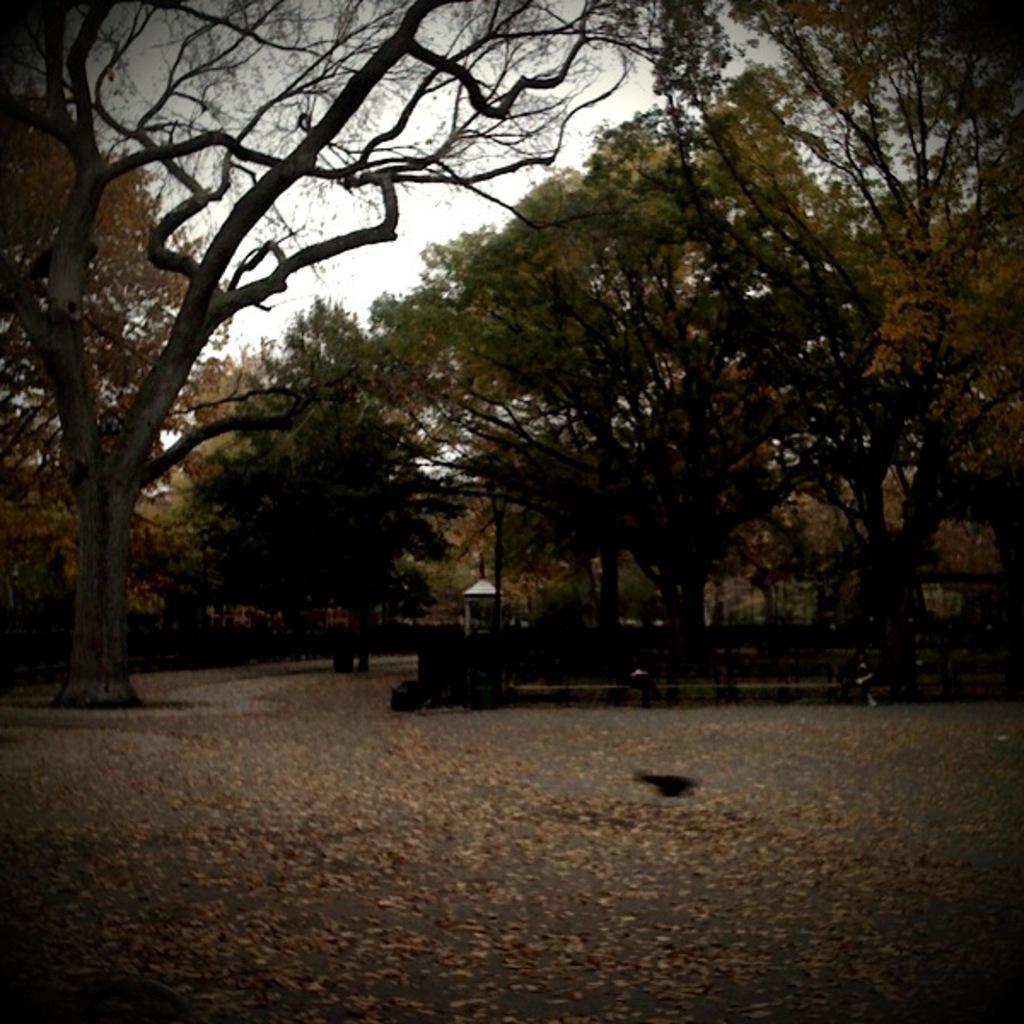Please provide a concise description of this image. In this picture we can see trees, at the bottom there are some leaves, it looks like a person is sitting on a bench on the right side, we can see the sky at the top of the picture. 